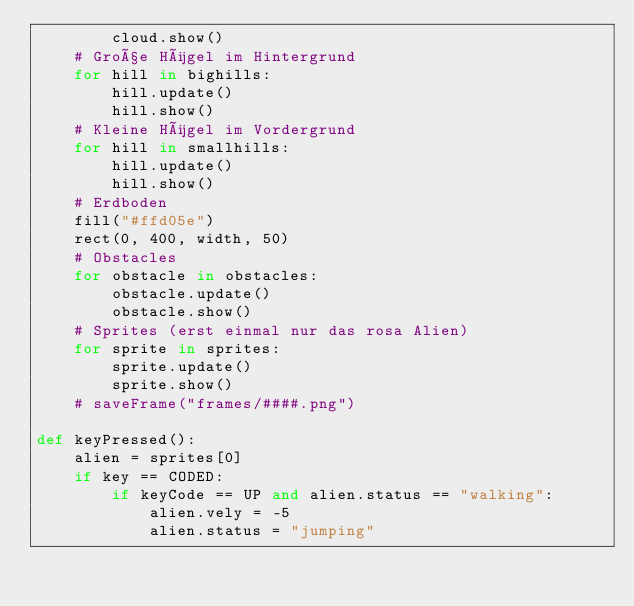<code> <loc_0><loc_0><loc_500><loc_500><_Python_>        cloud.show()
    # Große Hügel im Hintergrund
    for hill in bighills:
        hill.update()
        hill.show()
    # Kleine Hügel im Vordergrund         
    for hill in smallhills:
        hill.update()
        hill.show()
    # Erdboden    
    fill("#ffd05e")
    rect(0, 400, width, 50)
    # Obstacles
    for obstacle in obstacles:
        obstacle.update()
        obstacle.show()
    # Sprites (erst einmal nur das rosa Alien)
    for sprite in sprites:
        sprite.update()
        sprite.show()
    # saveFrame("frames/####.png")

def keyPressed():
    alien = sprites[0]
    if key == CODED:
        if keyCode == UP and alien.status == "walking":
            alien.vely = -5
            alien.status = "jumping"
    
</code> 